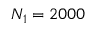<formula> <loc_0><loc_0><loc_500><loc_500>N _ { 1 } = 2 0 0 0</formula> 